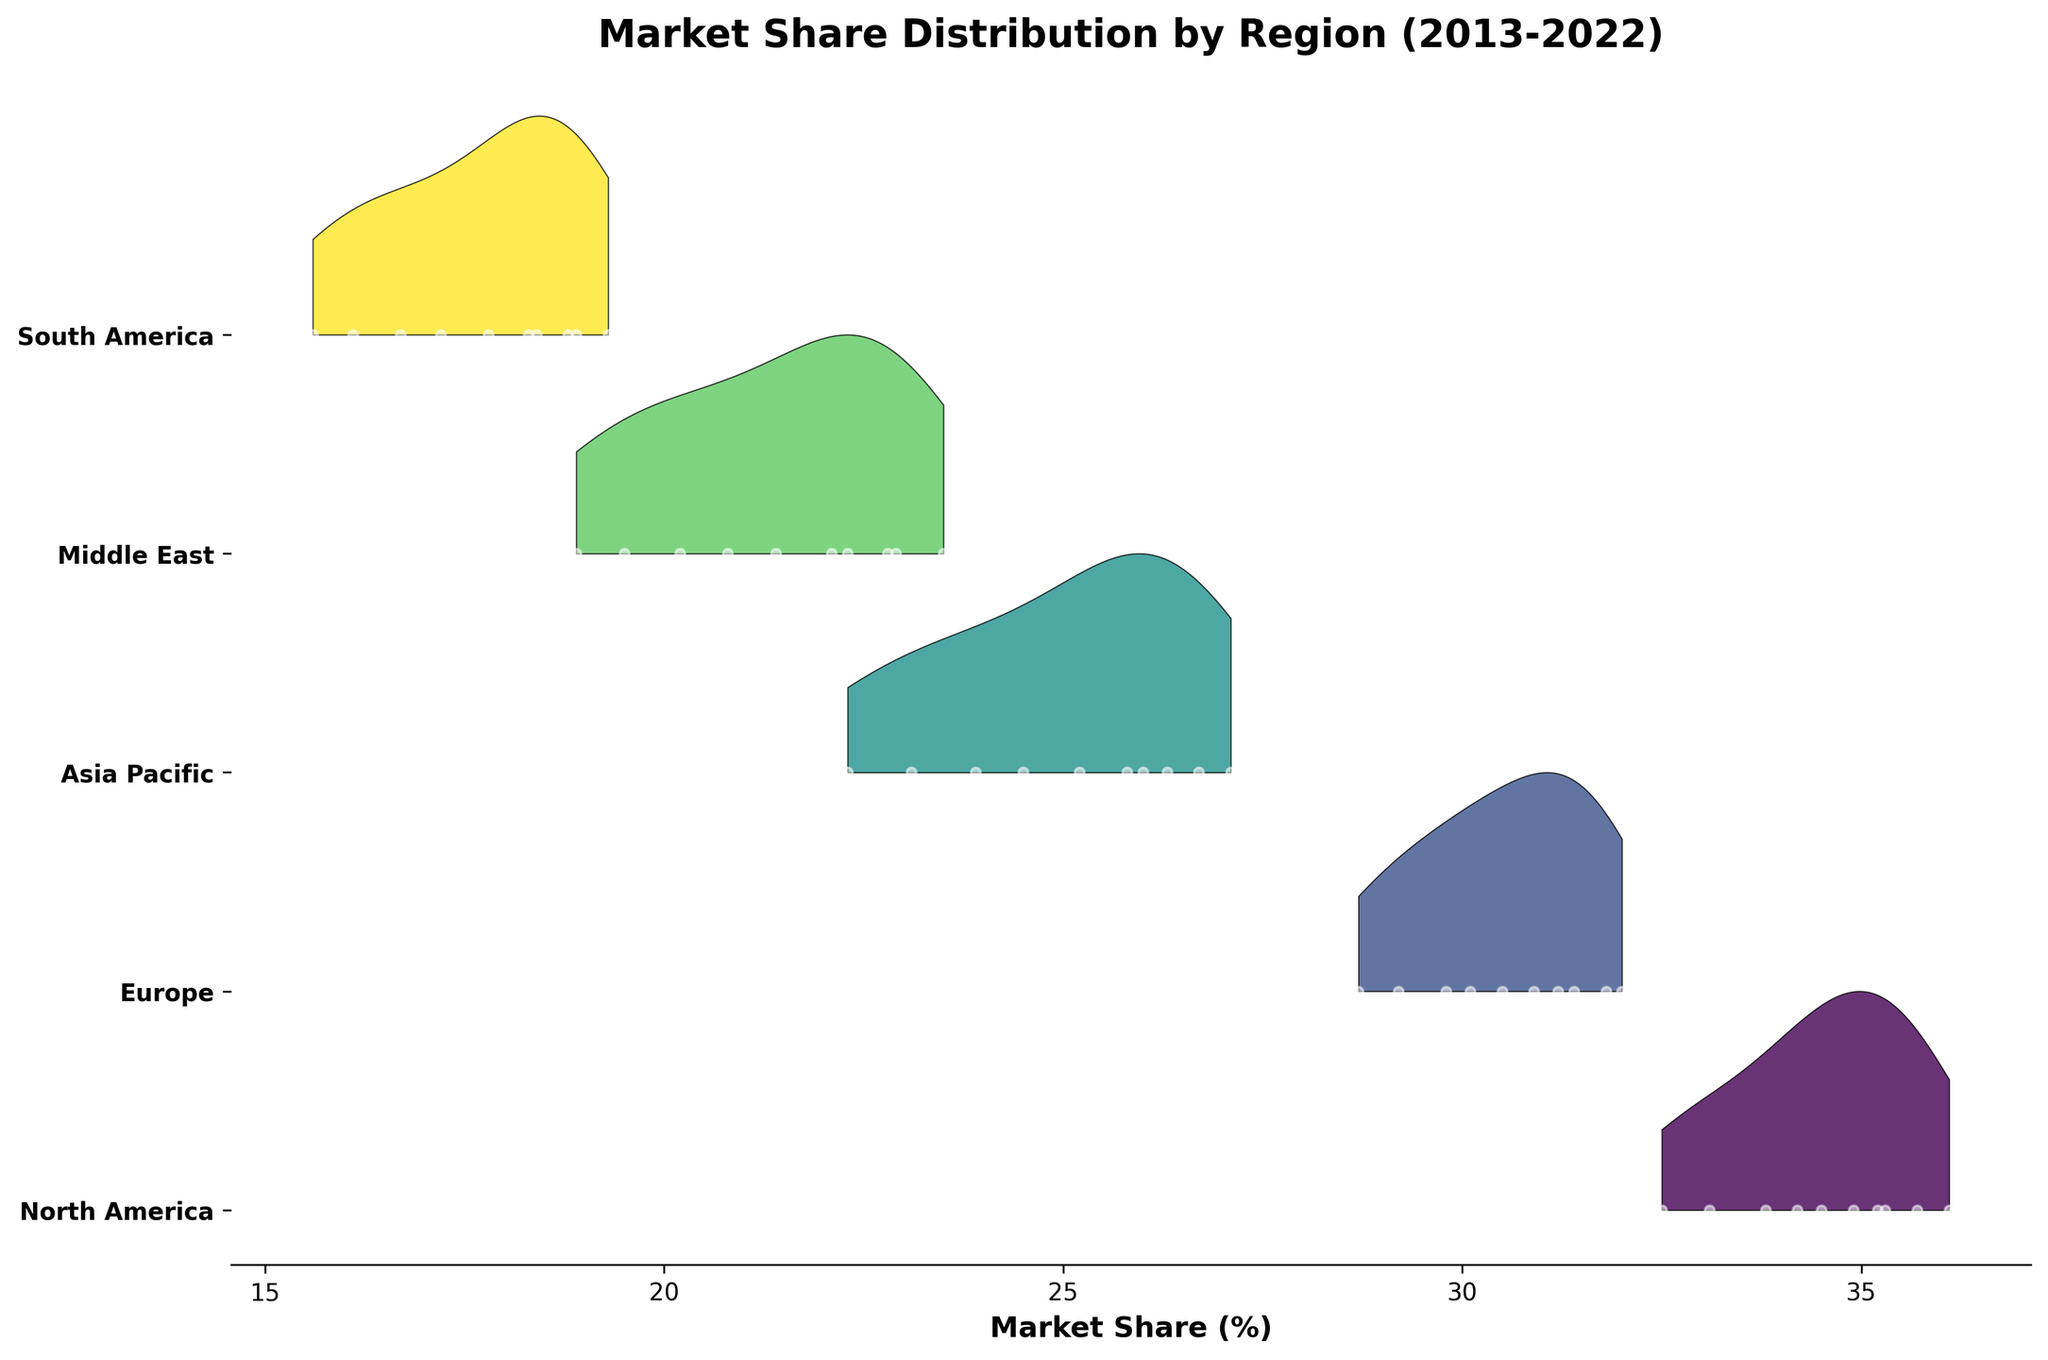What's the title of the figure? The title is displayed at the top of the plot, which is common in visual data presentations. It summarizes the content of the plot.
Answer: Market Share Distribution by Region (2013-2022) Which region shows the highest market share in 2022? The filled areas in the Ridgeline plot and the markers indicate the market share distribution. By checking the peak position of each region, ExxonMobil in North America holds the highest market share in 2022.
Answer: North America How does the market share of Shell in Europe change from 2020 to 2022? We need to locate the position of Shell and compare the height of the filled areas at positions corresponding to 2020 and 2022 to observe if it has moved up or down.
Answer: Increased Which company has consistently increased its market share over the decade presented in the figure? By noting the upward trend in the filled areas through the years, Shell in Europe shows a consistent increase without any drops in market share percentage.
Answer: Shell Between 2017 and 2018, which region showed the largest increase in market share? By examining the 2017 and 2018 ridges and comparing the vertical position changes of the filled areas between these two years, North America exhibits the largest increase.
Answer: North America Is there any region with a significant drop in market share in 2020? By observing the plot for a dip in the filled areas in 2020, both the Asia Pacific and South America regions show noticeable drops, but Asia Pacific shows a more significant decrease.
Answer: Asia Pacific Which region appears to have the most variability in market share percentages over the years? Viewing the spread and fluctuations of the filled areas and markers in the plot can help identify the variability. North America shows noticeable fluctuations compared to other regions.
Answer: North America How does PetroChina's market share in 2016 compare to 2021 in the Asia Pacific region? First, identify the ridges for the Asia Pacific region for the years 2016 and 2021 and compare their heights. The 2021 ridge is higher indicating an increase from 2016.
Answer: Increased What is the trend of Saudi Aramco's market share in the Middle East from 2013 to 2022? By following the filled area for the Middle East from 2013 to 2022, it shows a general upward trend with minor fluctuations.
Answer: Upward trend Comparing the market share of Petrobras in South America in 2015 and 2022, which year had a higher market share? By looking at the ridges for South America in the two years, the market share in 2022 is higher compared to 2015.
Answer: 2022 